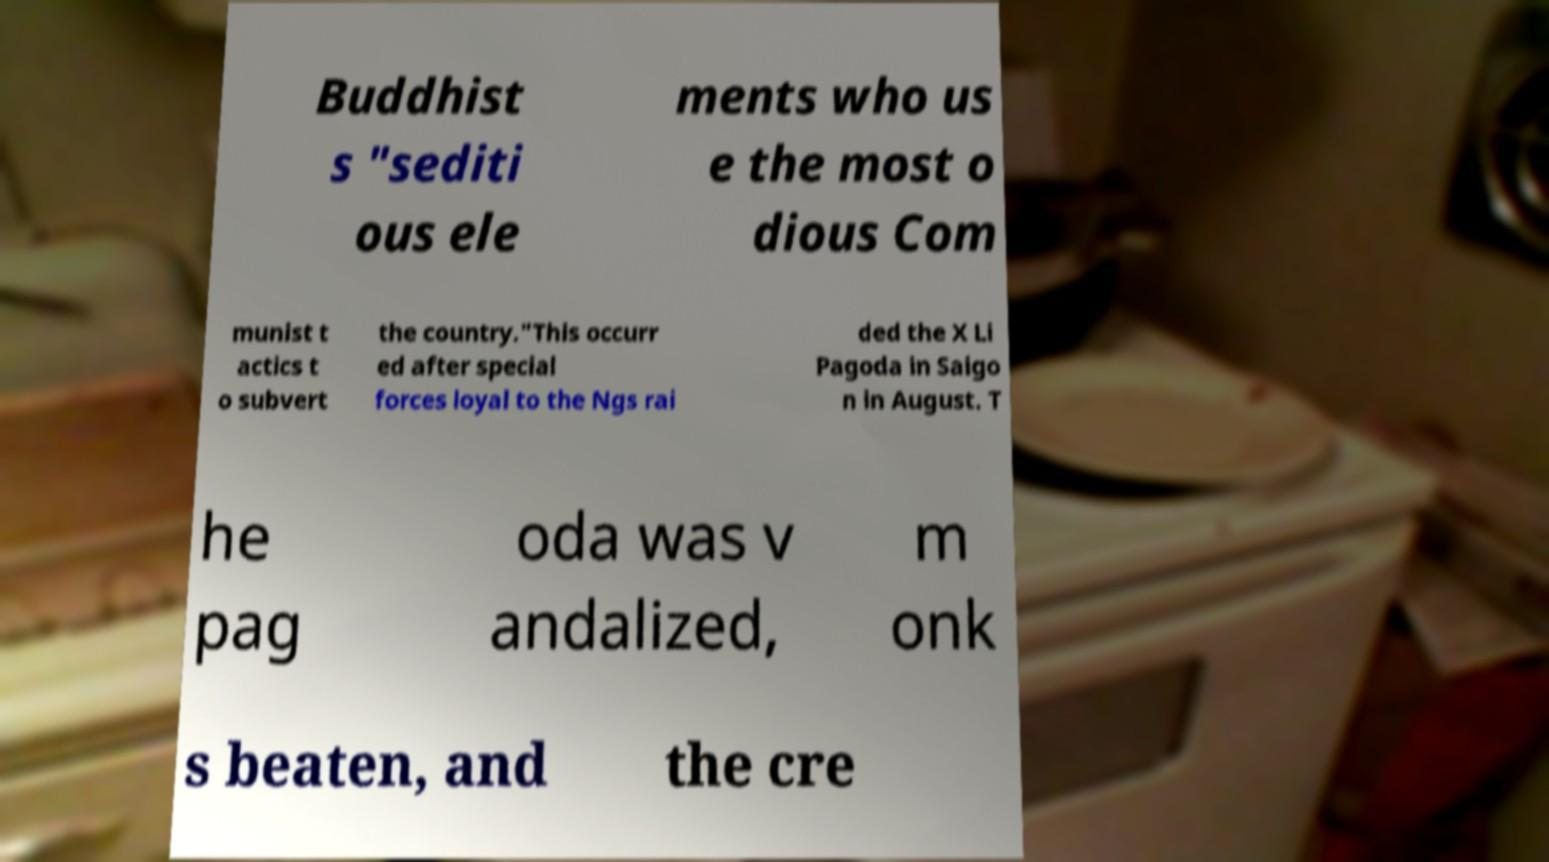Can you accurately transcribe the text from the provided image for me? Buddhist s "sediti ous ele ments who us e the most o dious Com munist t actics t o subvert the country."This occurr ed after special forces loyal to the Ngs rai ded the X Li Pagoda in Saigo n in August. T he pag oda was v andalized, m onk s beaten, and the cre 